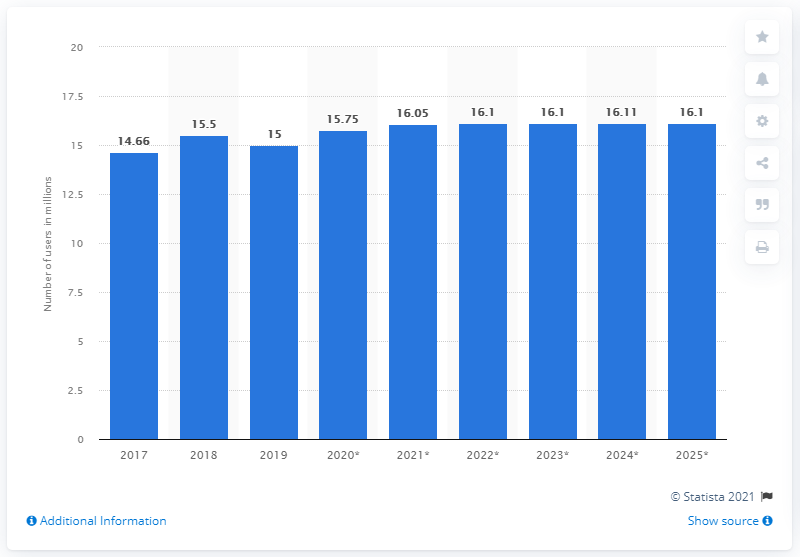Indicate a few pertinent items in this graphic. The expected number of Facebook users in South Korea in 2025 was 16.1 million. In 2019, there were 15 million people in South Korea who used Facebook. 